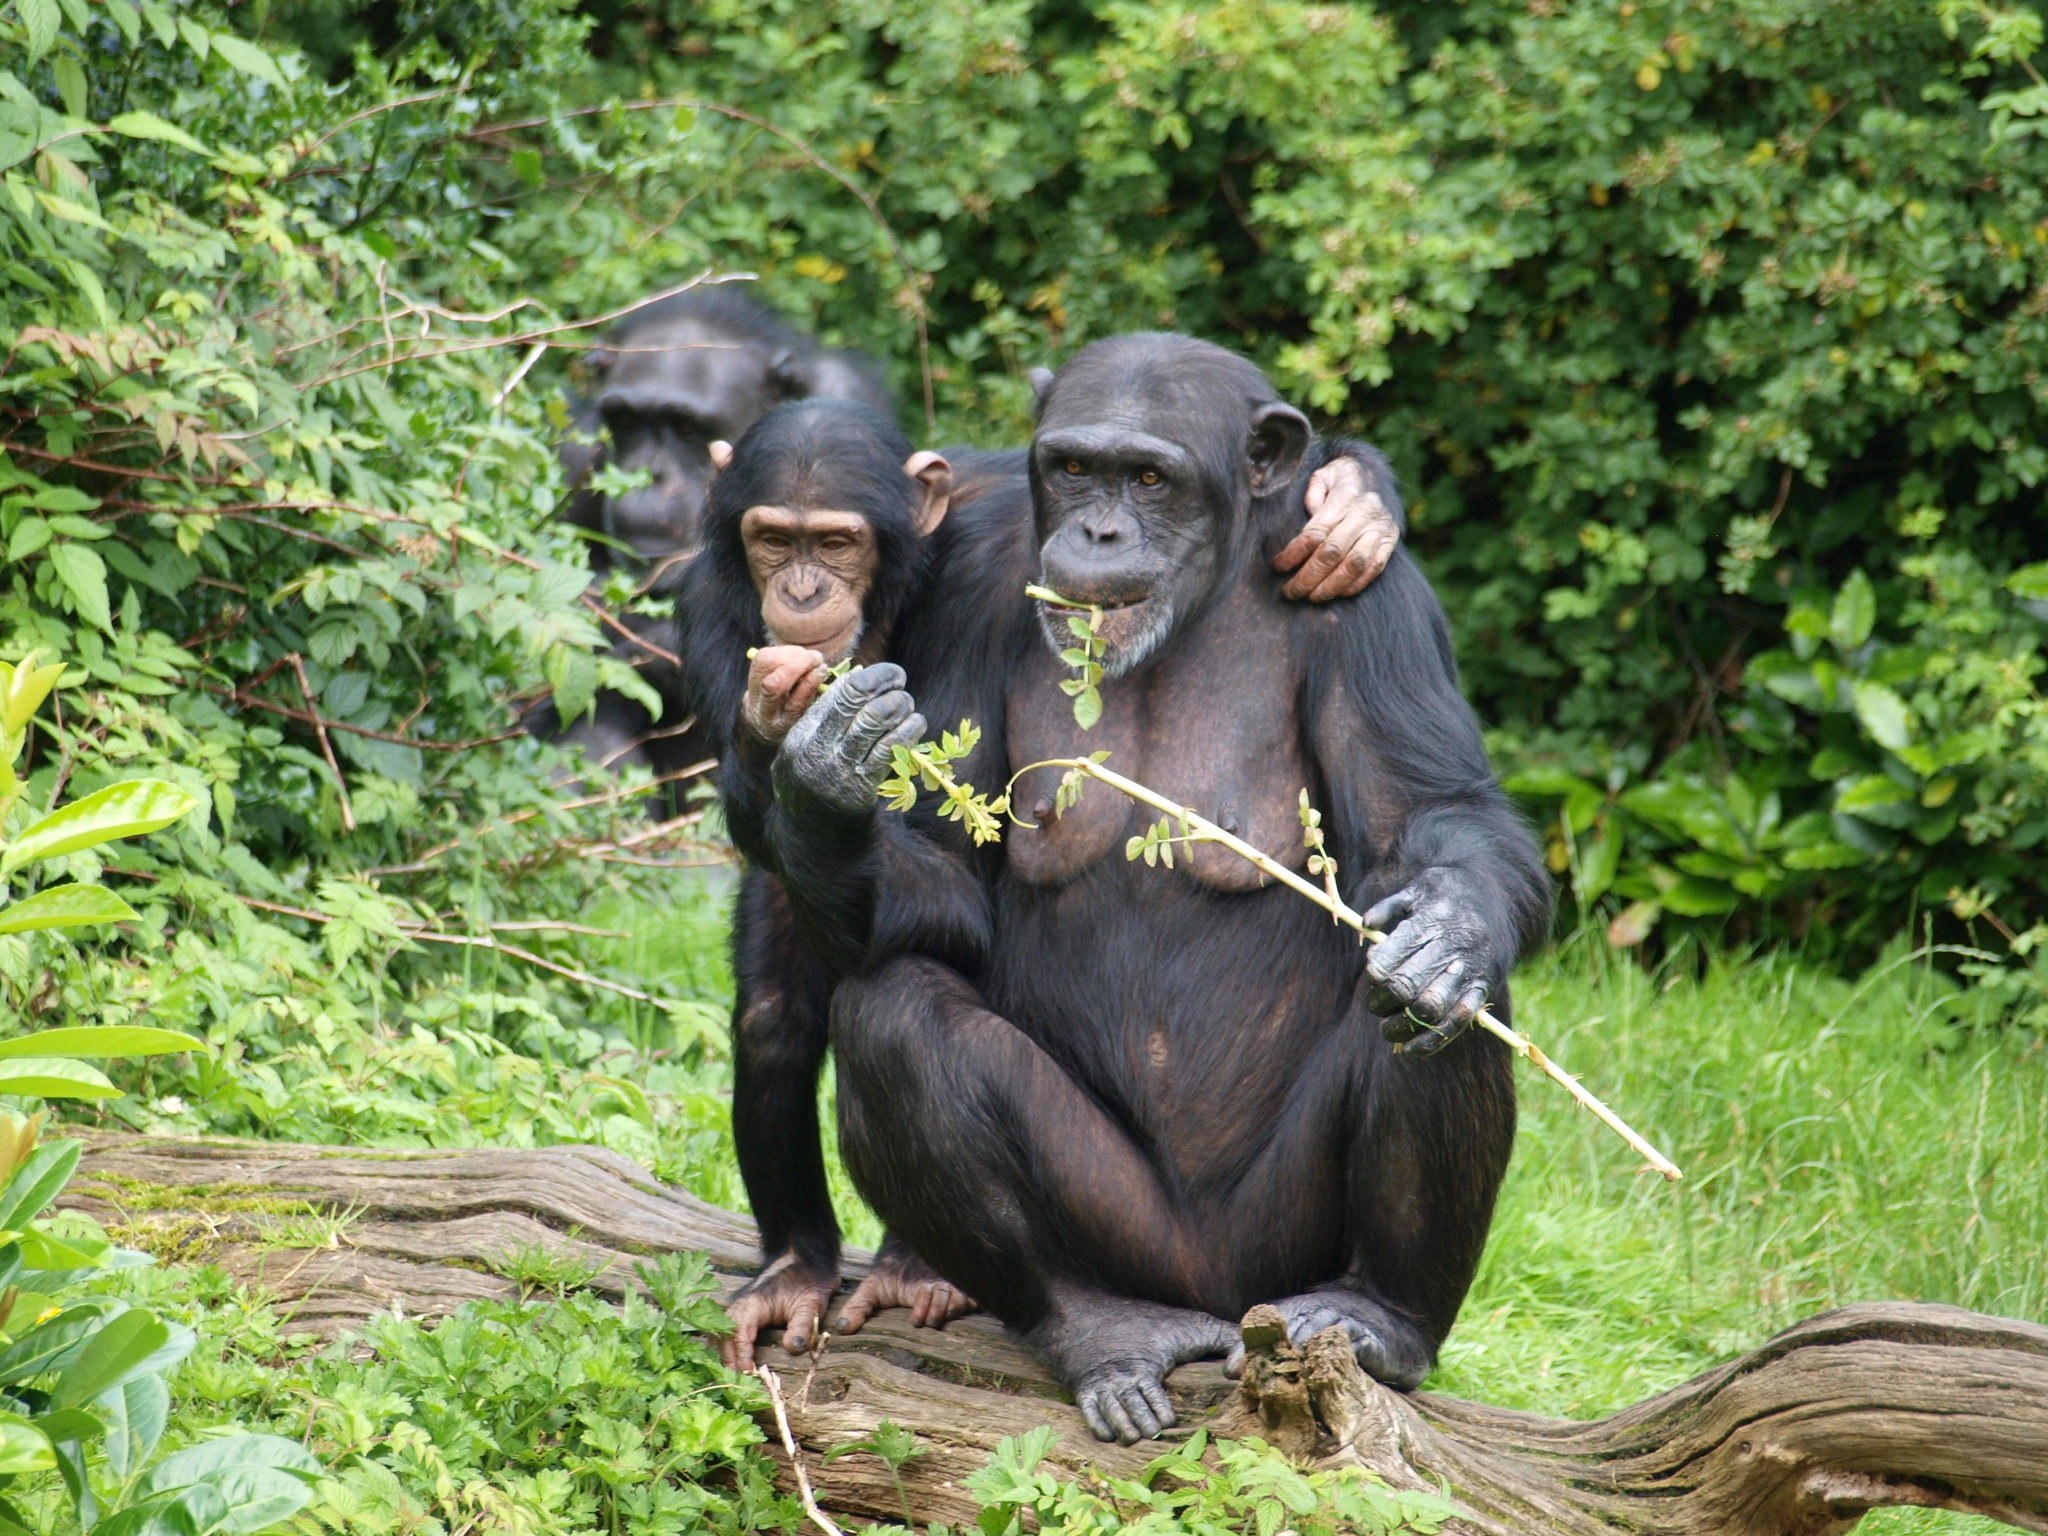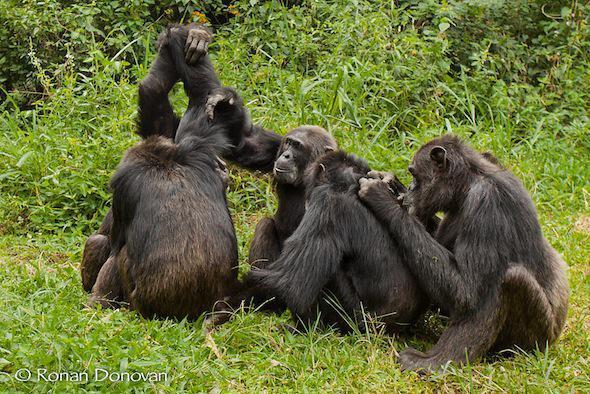The first image is the image on the left, the second image is the image on the right. Evaluate the accuracy of this statement regarding the images: "At least one primate in one of the images is sitting on a branch.". Is it true? Answer yes or no. Yes. The first image is the image on the left, the second image is the image on the right. Given the left and right images, does the statement "An image includes at least one chimp sitting behind another chimp and grooming its fur." hold true? Answer yes or no. Yes. 